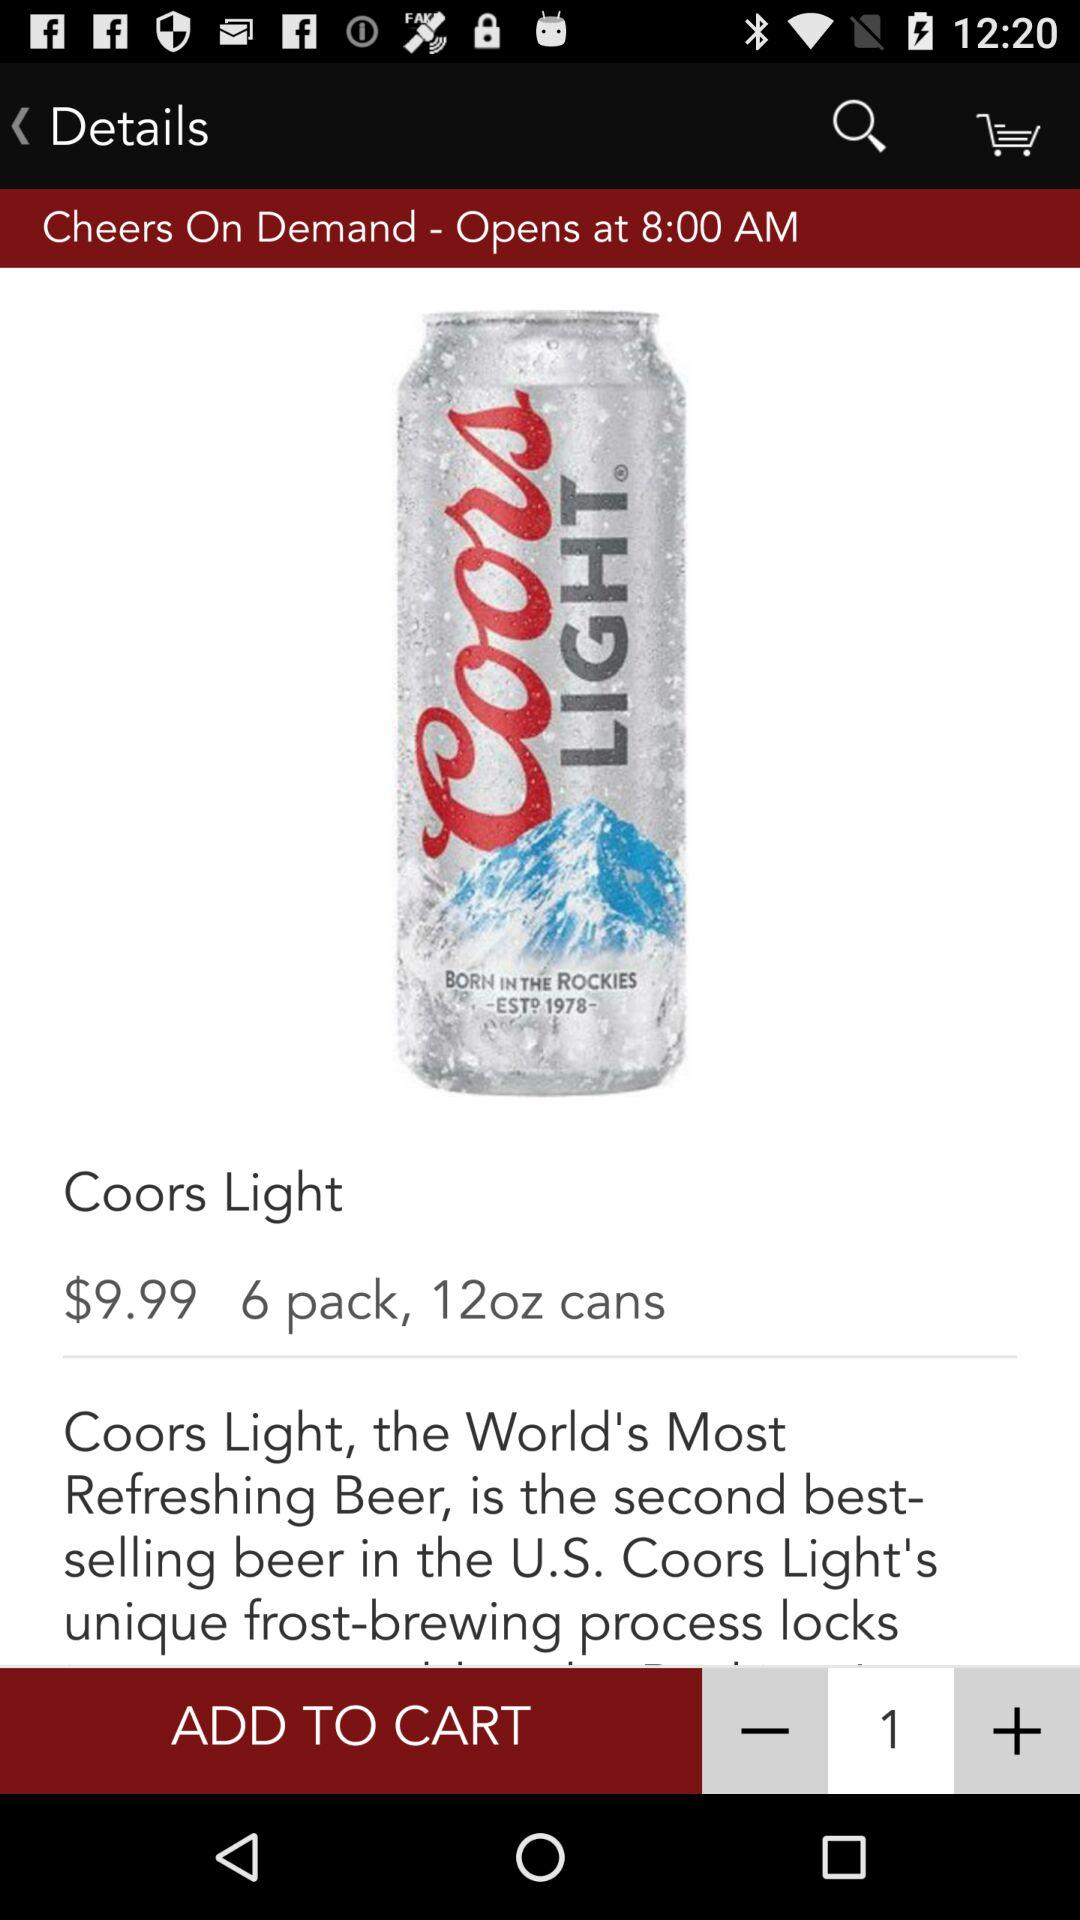How many items are in the cart?
When the provided information is insufficient, respond with <no answer>. <no answer> 